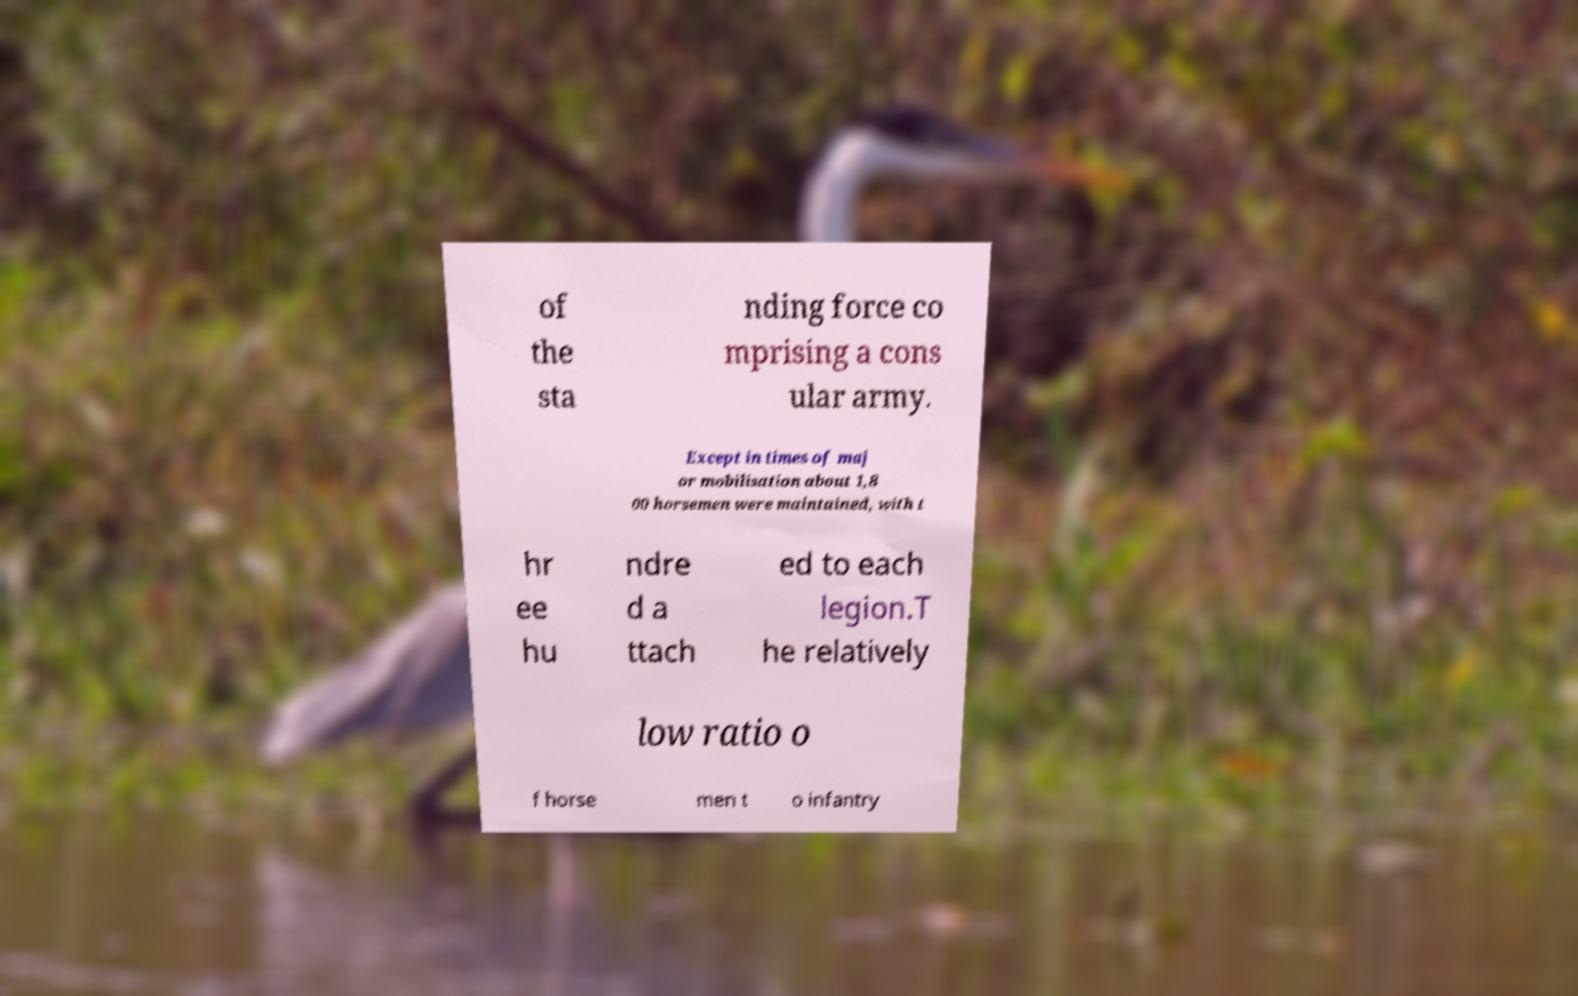Could you extract and type out the text from this image? of the sta nding force co mprising a cons ular army. Except in times of maj or mobilisation about 1,8 00 horsemen were maintained, with t hr ee hu ndre d a ttach ed to each legion.T he relatively low ratio o f horse men t o infantry 